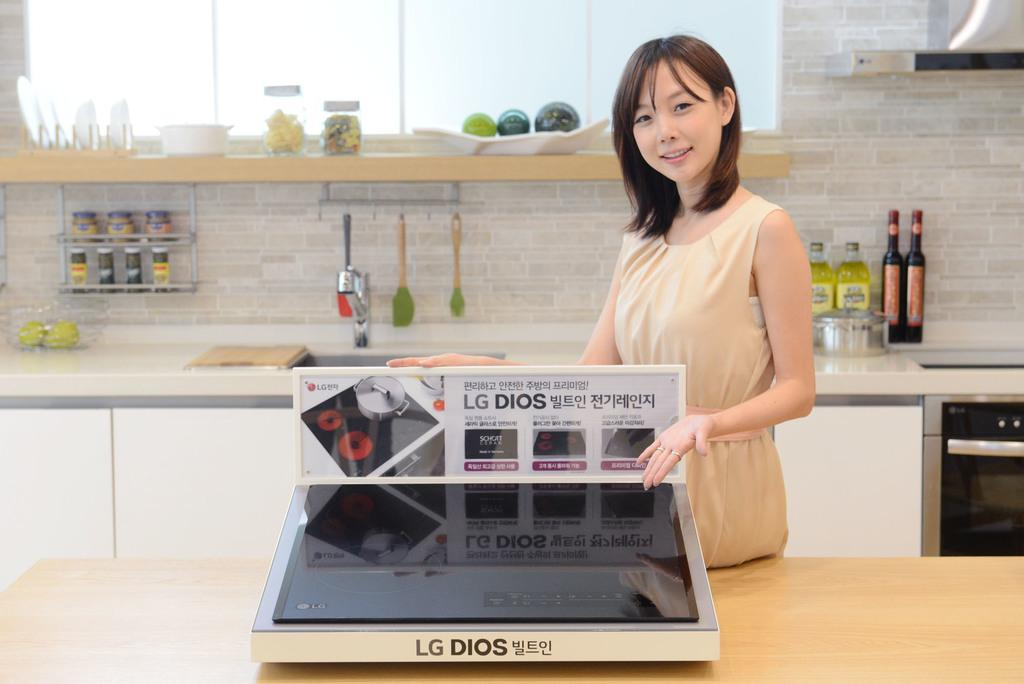Provide a one-sentence caption for the provided image. a woman standing in a kitchen holding an LG DIOS machine. 